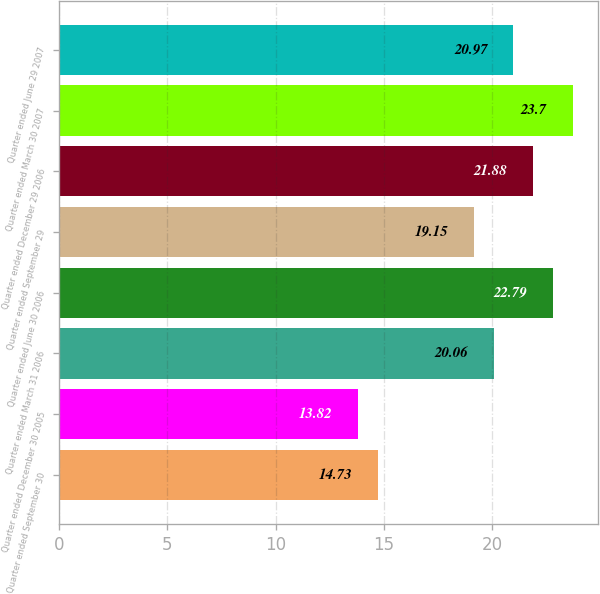Convert chart to OTSL. <chart><loc_0><loc_0><loc_500><loc_500><bar_chart><fcel>Quarter ended September 30<fcel>Quarter ended December 30 2005<fcel>Quarter ended March 31 2006<fcel>Quarter ended June 30 2006<fcel>Quarter ended September 29<fcel>Quarter ended December 29 2006<fcel>Quarter ended March 30 2007<fcel>Quarter ended June 29 2007<nl><fcel>14.73<fcel>13.82<fcel>20.06<fcel>22.79<fcel>19.15<fcel>21.88<fcel>23.7<fcel>20.97<nl></chart> 